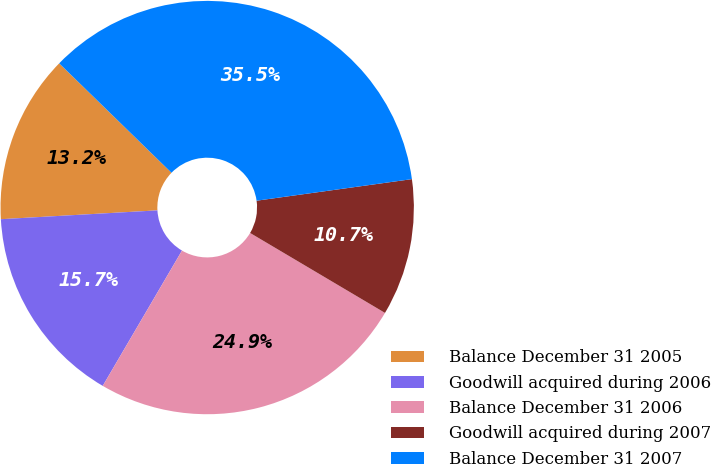<chart> <loc_0><loc_0><loc_500><loc_500><pie_chart><fcel>Balance December 31 2005<fcel>Goodwill acquired during 2006<fcel>Balance December 31 2006<fcel>Goodwill acquired during 2007<fcel>Balance December 31 2007<nl><fcel>13.19%<fcel>15.67%<fcel>24.92%<fcel>10.71%<fcel>35.51%<nl></chart> 